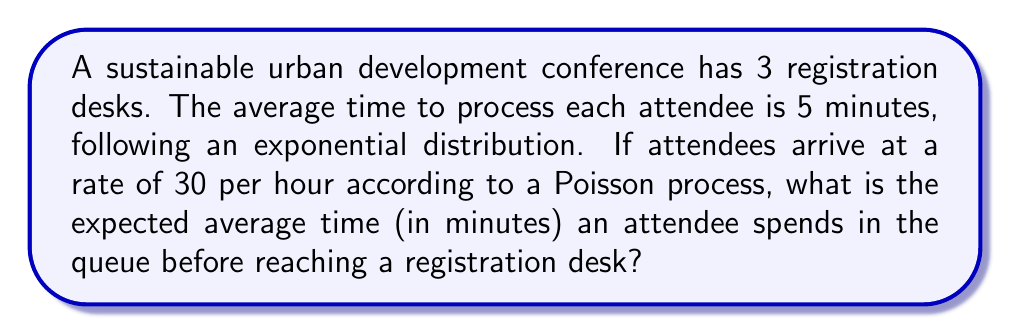Give your solution to this math problem. To solve this problem, we'll use the M/M/s queueing model, where:
M: Markovian arrival process (Poisson)
M: Markovian service times (exponential)
s: Number of servers (registration desks)

Step 1: Calculate the arrival rate (λ) and service rate (μ)
λ = 30 attendees/hour = 0.5 attendees/minute
μ = 1/5 = 0.2 attendees/minute per desk

Step 2: Calculate the utilization factor (ρ)
$$\rho = \frac{\lambda}{s\mu} = \frac{0.5}{3 \cdot 0.2} = \frac{5}{6} \approx 0.833$$

Step 3: Calculate the probability of an empty system (P₀)
$$P_0 = \left[\sum_{n=0}^{s-1}\frac{1}{n!}\left(\frac{\lambda}{\mu}\right)^n + \frac{1}{s!}\left(\frac{\lambda}{\mu}\right)^s\frac{s\mu}{s\mu-\lambda}\right]^{-1}$$
$$P_0 = \left[1 + \frac{5}{2} + \frac{25}{12} + \frac{125}{36} \cdot \frac{3}{1}\right]^{-1} \approx 0.0398$$

Step 4: Calculate the expected number of attendees in the queue (Lq)
$$L_q = \frac{P_0(\lambda/\mu)^s\rho}{s!(1-\rho)^2}$$
$$L_q = \frac{0.0398 \cdot (2.5)^3 \cdot (5/6)}{6 \cdot (1/6)^2} \approx 2.0833$$

Step 5: Calculate the expected time in the queue (Wq) using Little's Law
$$W_q = \frac{L_q}{\lambda} = \frac{2.0833}{0.5} = 4.1666$$

Therefore, the expected average time an attendee spends in the queue is approximately 4.17 minutes.
Answer: 4.17 minutes 